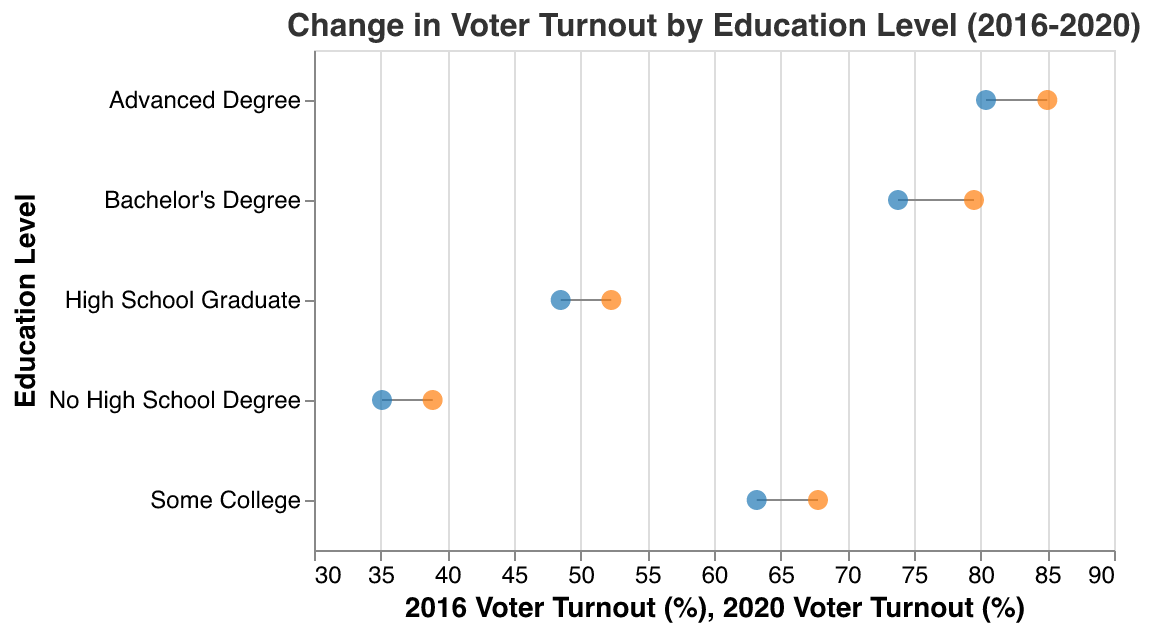What's the title of the figure? The title of the figure is located at the top and usually describes the overall content. From the code, the title reads "Change in Voter Turnout by Education Level (2016-2020)".
Answer: "Change in Voter Turnout by Education Level (2016-2020)" What is the voter turnout rate for "High School Graduate" in 2020? We can find the voter turnout rates directly on the horizontal axis values associated with each education level. For "High School Graduate," the rate in 2020 is 52.3%.
Answer: 52.3% How many different education levels are displayed in this figure? By counting the unique education levels listed on the vertical axis, we see there are five: "No High School Degree," "High School Graduate," "Some College," "Bachelor's Degree," and "Advanced Degree."
Answer: 5 Which education level had the largest increase in voter turnout from 2016 to 2020? To determine the largest increase, we calculate the difference between the 2020 and 2016 values for each education level. "Advanced Degree" increased from 80.4% to 85.0%, a 4.6% increase.
Answer: "Advanced Degree" What is the average voter turnout in 2020 across all education levels shown? We calculate the average by summing the 2020 voter turnout rates and dividing by the number of education levels. (38.9 + 52.3 + 67.8 + 79.5 + 85.0)/5 = 64.7.
Answer: 64.7% Which education level had the smallest change in voter turnout between the two elections? By calculating the differences for each education level, "No High School Degree" had the smallest change from 35.1% to 38.9%, which is a 3.8% increase.
Answer: "No High School Degree" Does having a higher education level correlate with a higher voter turnout increase from 2016 to 2020? By comparing the education levels with their respective increases in voter turnout, we observe that higher education levels tend to show higher increases, such as "Bachelor's Degree" and "Advanced Degree".
Answer: Yes Compare the voter turnout changes for "Some College" and "Bachelor's Degree". Which saw a larger increase? Subtract the voter turnout rates of 2016 from 2020 for both. "Some College" had a 4.6% increase (67.8% - 63.2%) and "Bachelor's Degree" also had a 5.7% increase (79.5% - 73.8%). Therefore, "Bachelor's Degree" saw a larger increase.
Answer: "Bachelor's Degree" What is the combined voter turnout for "No High School Degree" for both elections? Add the voter turnout from both elections for "No High School Degree": 35.1 + 38.9 = 74.0.
Answer: 74.0% Which education level has the highest voter turnout rate in 2020, and what is the value? Identify the education level with the highest value for 2020 voter turnout, which is "Advanced Degree" at 85.0%.
Answer: "Advanced Degree" at 85.0% 